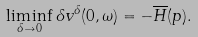<formula> <loc_0><loc_0><loc_500><loc_500>\liminf _ { \delta \to 0 } \delta v ^ { \delta } ( 0 , \omega ) = - \overline { H } ( p ) .</formula> 